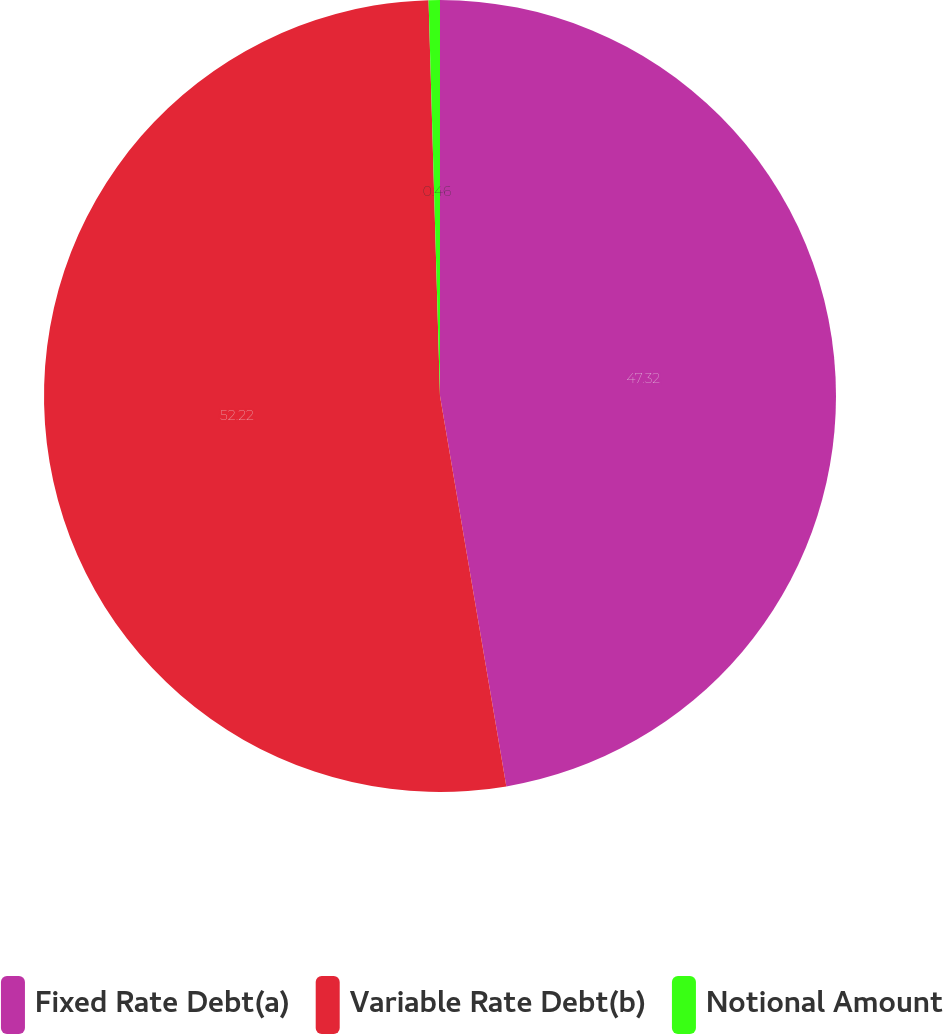Convert chart. <chart><loc_0><loc_0><loc_500><loc_500><pie_chart><fcel>Fixed Rate Debt(a)<fcel>Variable Rate Debt(b)<fcel>Notional Amount<nl><fcel>47.32%<fcel>52.22%<fcel>0.46%<nl></chart> 